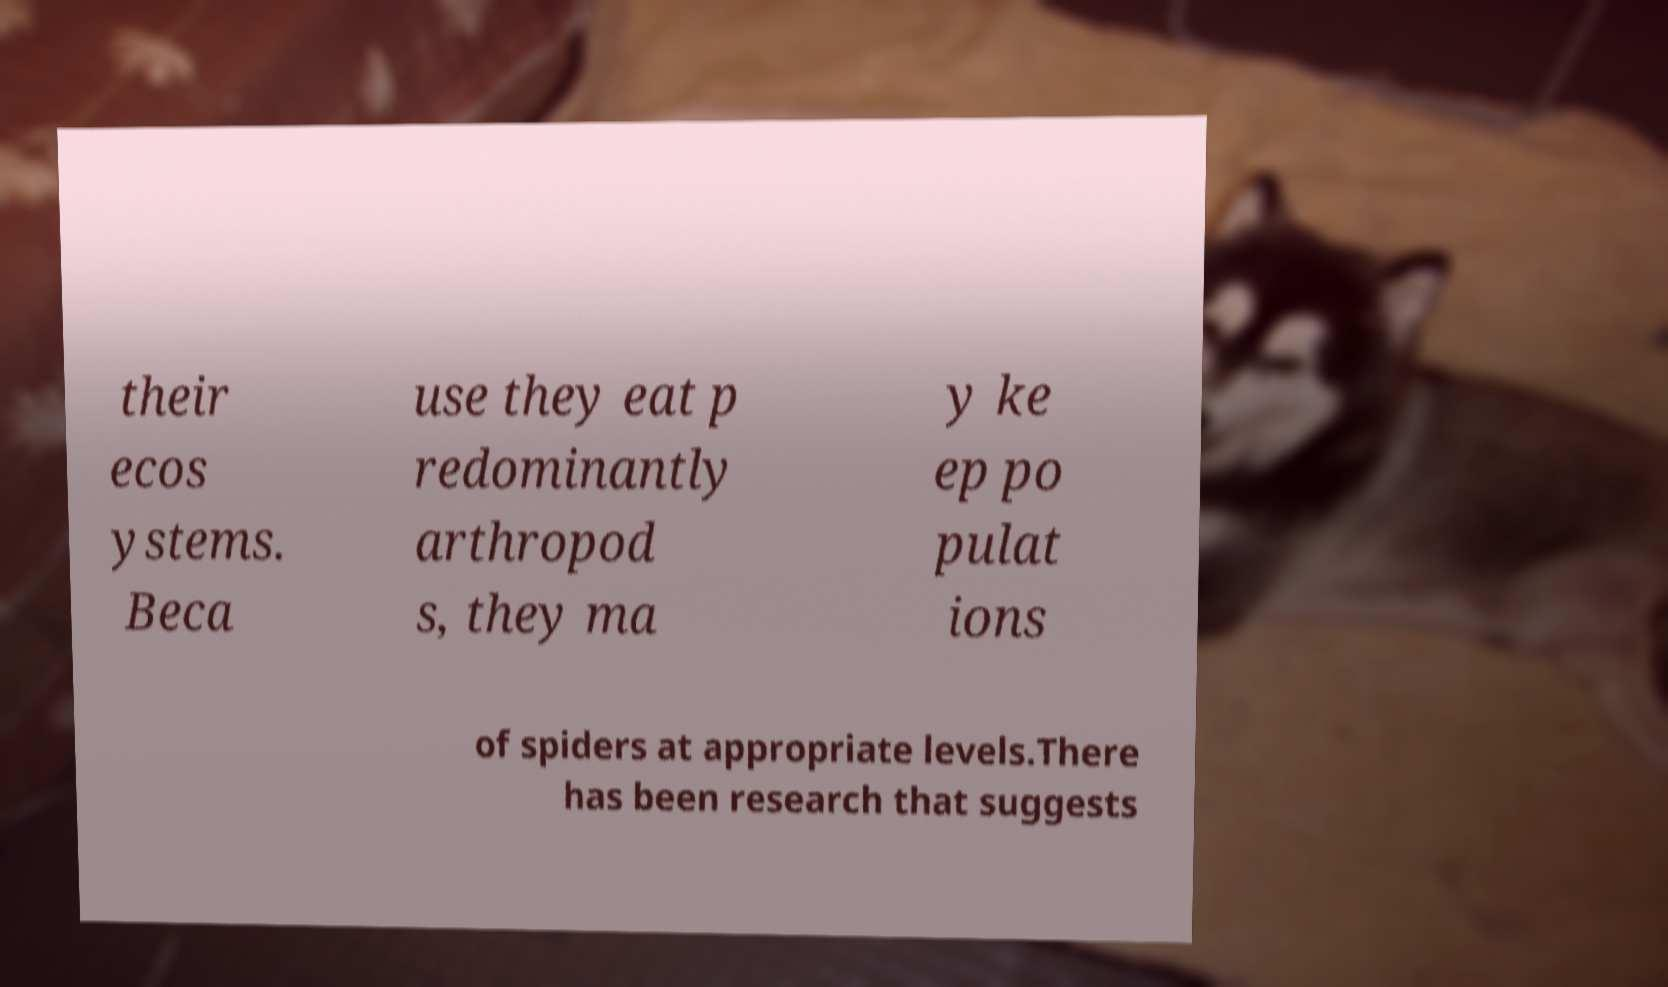Can you accurately transcribe the text from the provided image for me? their ecos ystems. Beca use they eat p redominantly arthropod s, they ma y ke ep po pulat ions of spiders at appropriate levels.There has been research that suggests 